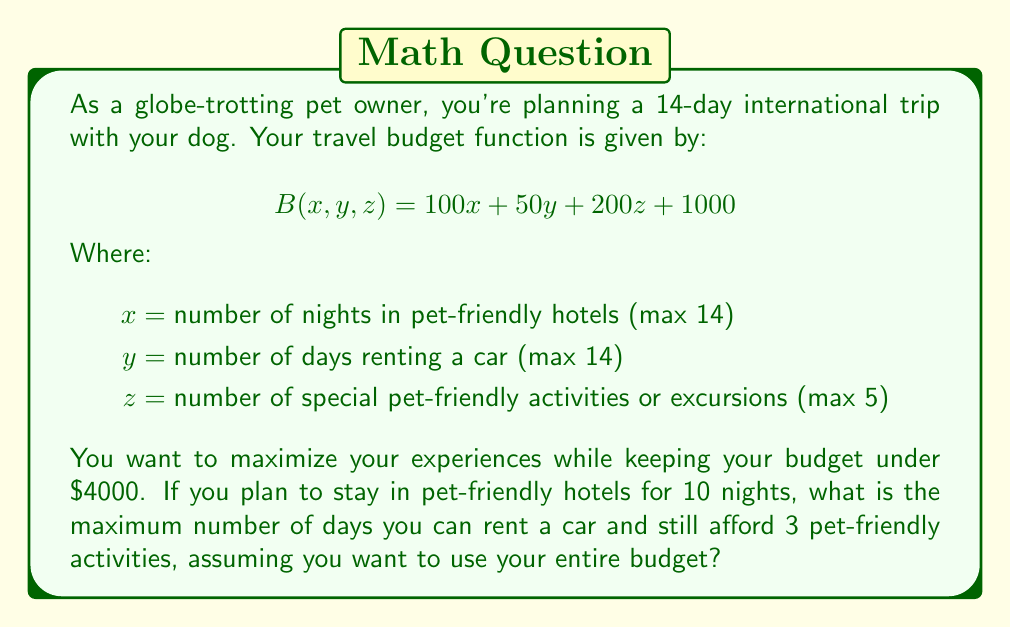What is the answer to this math problem? Let's approach this step-by-step:

1) We start with the budget function:
   $$B(x, y, z) = 100x + 50y + 200z + 1000$$

2) We know some values:
   $x = 10$ (nights in pet-friendly hotels)
   $z = 3$ (pet-friendly activities)
   We need to solve for $y$ (days renting a car)

3) We want to use the entire budget of $4000, so we set up the equation:
   $$4000 = 100(10) + 50y + 200(3) + 1000$$

4) Let's simplify:
   $$4000 = 1000 + 50y + 600 + 1000$$
   $$4000 = 2600 + 50y$$

5) Subtract 2600 from both sides:
   $$1400 = 50y$$

6) Divide both sides by 50:
   $$28 = y$$

7) However, remember that $y$ has a maximum value of 14 (the length of the trip). Therefore, we need to limit our answer to 14.
Answer: The maximum number of days you can rent a car while staying within budget is 14 days. 